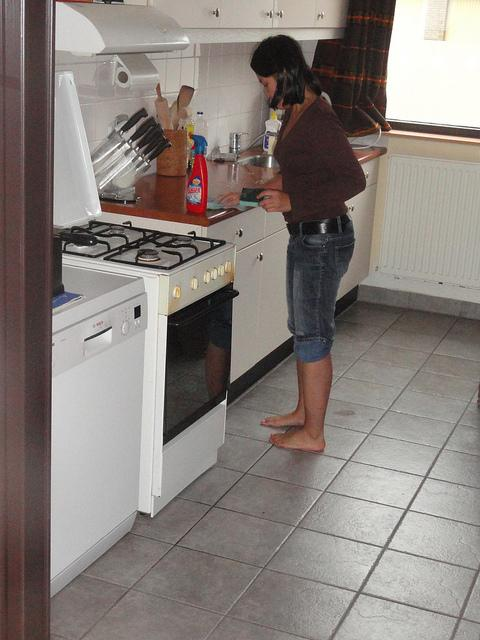What is the person doing in the kitchen?

Choices:
A) sleeping
B) meddling
C) cleaning
D) cooking cleaning 